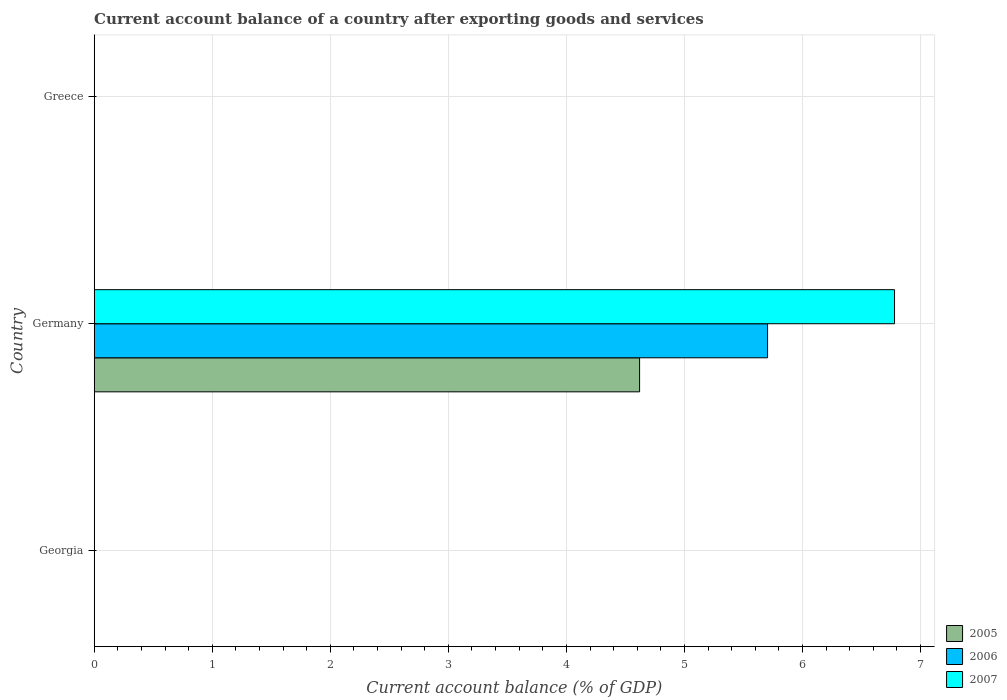How many different coloured bars are there?
Your response must be concise. 3. Are the number of bars per tick equal to the number of legend labels?
Give a very brief answer. No. Are the number of bars on each tick of the Y-axis equal?
Provide a short and direct response. No. How many bars are there on the 2nd tick from the top?
Offer a terse response. 3. In how many cases, is the number of bars for a given country not equal to the number of legend labels?
Offer a very short reply. 2. Across all countries, what is the maximum account balance in 2007?
Offer a very short reply. 6.78. Across all countries, what is the minimum account balance in 2006?
Make the answer very short. 0. In which country was the account balance in 2006 maximum?
Your answer should be compact. Germany. What is the total account balance in 2007 in the graph?
Ensure brevity in your answer.  6.78. What is the average account balance in 2007 per country?
Keep it short and to the point. 2.26. What is the difference between the account balance in 2007 and account balance in 2006 in Germany?
Offer a very short reply. 1.08. What is the difference between the highest and the lowest account balance in 2005?
Your response must be concise. 4.62. How many countries are there in the graph?
Offer a terse response. 3. Are the values on the major ticks of X-axis written in scientific E-notation?
Your answer should be compact. No. Does the graph contain any zero values?
Offer a terse response. Yes. How are the legend labels stacked?
Make the answer very short. Vertical. What is the title of the graph?
Provide a succinct answer. Current account balance of a country after exporting goods and services. Does "2011" appear as one of the legend labels in the graph?
Offer a terse response. No. What is the label or title of the X-axis?
Make the answer very short. Current account balance (% of GDP). What is the label or title of the Y-axis?
Ensure brevity in your answer.  Country. What is the Current account balance (% of GDP) of 2007 in Georgia?
Your answer should be very brief. 0. What is the Current account balance (% of GDP) of 2005 in Germany?
Provide a succinct answer. 4.62. What is the Current account balance (% of GDP) of 2006 in Germany?
Offer a very short reply. 5.7. What is the Current account balance (% of GDP) in 2007 in Germany?
Your response must be concise. 6.78. What is the Current account balance (% of GDP) in 2005 in Greece?
Offer a very short reply. 0. Across all countries, what is the maximum Current account balance (% of GDP) in 2005?
Your response must be concise. 4.62. Across all countries, what is the maximum Current account balance (% of GDP) of 2006?
Make the answer very short. 5.7. Across all countries, what is the maximum Current account balance (% of GDP) of 2007?
Provide a succinct answer. 6.78. What is the total Current account balance (% of GDP) in 2005 in the graph?
Provide a succinct answer. 4.62. What is the total Current account balance (% of GDP) of 2006 in the graph?
Make the answer very short. 5.7. What is the total Current account balance (% of GDP) of 2007 in the graph?
Provide a succinct answer. 6.78. What is the average Current account balance (% of GDP) in 2005 per country?
Provide a short and direct response. 1.54. What is the average Current account balance (% of GDP) in 2006 per country?
Keep it short and to the point. 1.9. What is the average Current account balance (% of GDP) in 2007 per country?
Your response must be concise. 2.26. What is the difference between the Current account balance (% of GDP) of 2005 and Current account balance (% of GDP) of 2006 in Germany?
Ensure brevity in your answer.  -1.08. What is the difference between the Current account balance (% of GDP) of 2005 and Current account balance (% of GDP) of 2007 in Germany?
Your answer should be very brief. -2.16. What is the difference between the Current account balance (% of GDP) in 2006 and Current account balance (% of GDP) in 2007 in Germany?
Ensure brevity in your answer.  -1.08. What is the difference between the highest and the lowest Current account balance (% of GDP) of 2005?
Offer a very short reply. 4.62. What is the difference between the highest and the lowest Current account balance (% of GDP) in 2006?
Provide a short and direct response. 5.7. What is the difference between the highest and the lowest Current account balance (% of GDP) of 2007?
Your answer should be very brief. 6.78. 